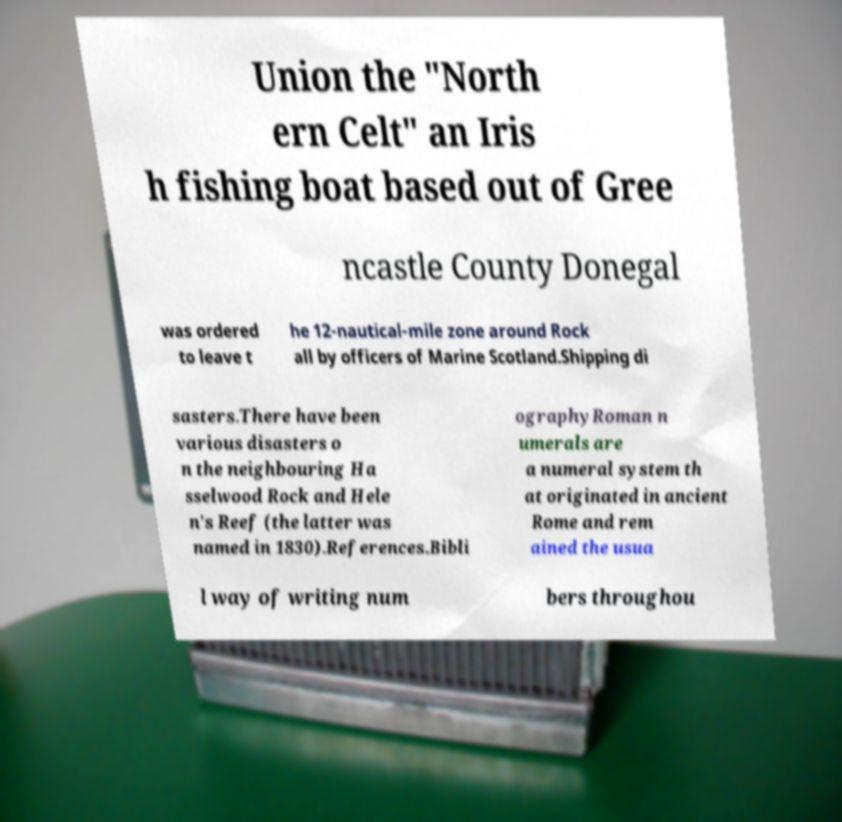What messages or text are displayed in this image? I need them in a readable, typed format. Union the "North ern Celt" an Iris h fishing boat based out of Gree ncastle County Donegal was ordered to leave t he 12-nautical-mile zone around Rock all by officers of Marine Scotland.Shipping di sasters.There have been various disasters o n the neighbouring Ha sselwood Rock and Hele n's Reef (the latter was named in 1830).References.Bibli ographyRoman n umerals are a numeral system th at originated in ancient Rome and rem ained the usua l way of writing num bers throughou 